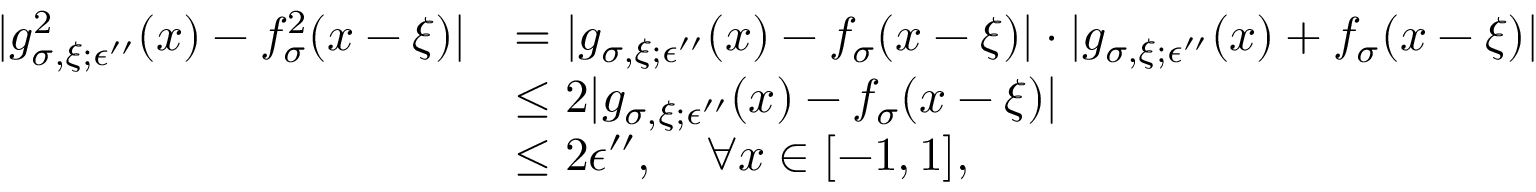<formula> <loc_0><loc_0><loc_500><loc_500>\begin{array} { r l } { | g _ { \sigma , \xi ; \epsilon ^ { \prime \prime } } ^ { 2 } ( x ) - f _ { \sigma } ^ { 2 } ( x - \xi ) | } & { = | g _ { \sigma , \xi ; \epsilon ^ { \prime \prime } } ( x ) - f _ { \sigma } ( x - \xi ) | \cdot | g _ { \sigma , \xi ; \epsilon ^ { \prime \prime } } ( x ) + f _ { \sigma } ( x - \xi ) | } \\ & { \leq 2 | g _ { \sigma , \xi ; \epsilon ^ { \prime \prime } } ( x ) - f _ { \sigma } ( x - \xi ) | } \\ & { \leq 2 \epsilon ^ { \prime \prime } , \forall x \in [ - 1 , 1 ] , } \end{array}</formula> 